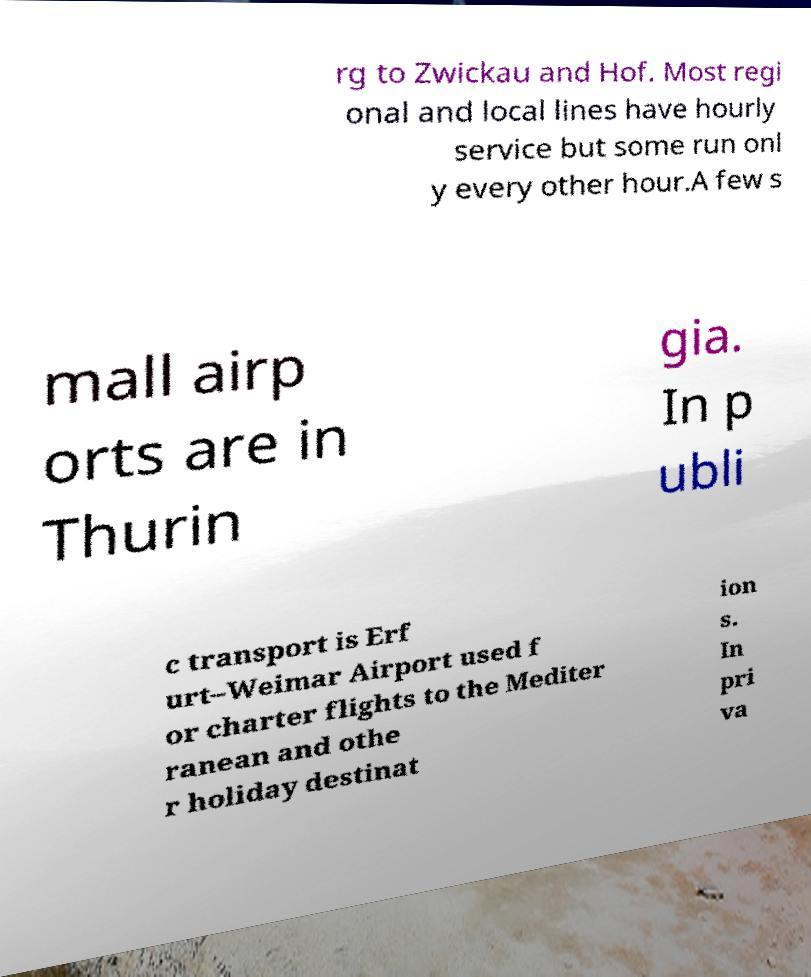There's text embedded in this image that I need extracted. Can you transcribe it verbatim? rg to Zwickau and Hof. Most regi onal and local lines have hourly service but some run onl y every other hour.A few s mall airp orts are in Thurin gia. In p ubli c transport is Erf urt–Weimar Airport used f or charter flights to the Mediter ranean and othe r holiday destinat ion s. In pri va 